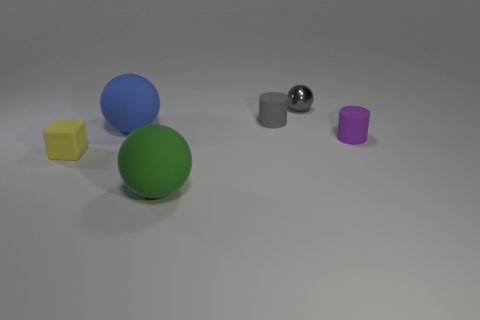How big is the thing that is right of the tiny metallic ball?
Provide a succinct answer. Small. Are there fewer tiny yellow matte objects than purple metal cubes?
Offer a terse response. No. Are there any metal blocks that have the same color as the tiny shiny object?
Provide a succinct answer. No. The small thing that is both in front of the small metallic object and behind the big blue matte thing has what shape?
Offer a terse response. Cylinder. What is the shape of the large rubber object to the left of the matte object in front of the small yellow rubber thing?
Ensure brevity in your answer.  Sphere. Is the shape of the purple matte thing the same as the gray matte thing?
Provide a short and direct response. Yes. There is a object that is the same color as the tiny ball; what material is it?
Your response must be concise. Rubber. Is the small metallic object the same color as the small cube?
Provide a short and direct response. No. There is a cylinder on the left side of the tiny cylinder in front of the gray cylinder; how many tiny gray shiny spheres are on the right side of it?
Your answer should be very brief. 1. What is the shape of the tiny yellow thing that is made of the same material as the gray cylinder?
Keep it short and to the point. Cube. 